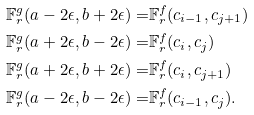Convert formula to latex. <formula><loc_0><loc_0><loc_500><loc_500>\mathbb { F } ^ { g } _ { r } ( a - 2 \epsilon , b + 2 \epsilon ) = & \mathbb { F } ^ { f } _ { r } ( c _ { i - 1 } , c _ { j + 1 } ) \\ \mathbb { F } ^ { g } _ { r } ( a + 2 \epsilon , b - 2 \epsilon ) = & \mathbb { F } ^ { f } _ { r } ( c _ { i } , c _ { j } ) \\ \mathbb { F } ^ { g } _ { r } ( a + 2 \epsilon , b + 2 \epsilon ) = & \mathbb { F } ^ { f } _ { r } ( c _ { i } , c _ { j + 1 } ) \\ \mathbb { F } ^ { g } _ { r } ( a - 2 \epsilon , b - 2 \epsilon ) = & \mathbb { F } ^ { f } _ { r } ( c _ { i - 1 } , c _ { j } ) .</formula> 